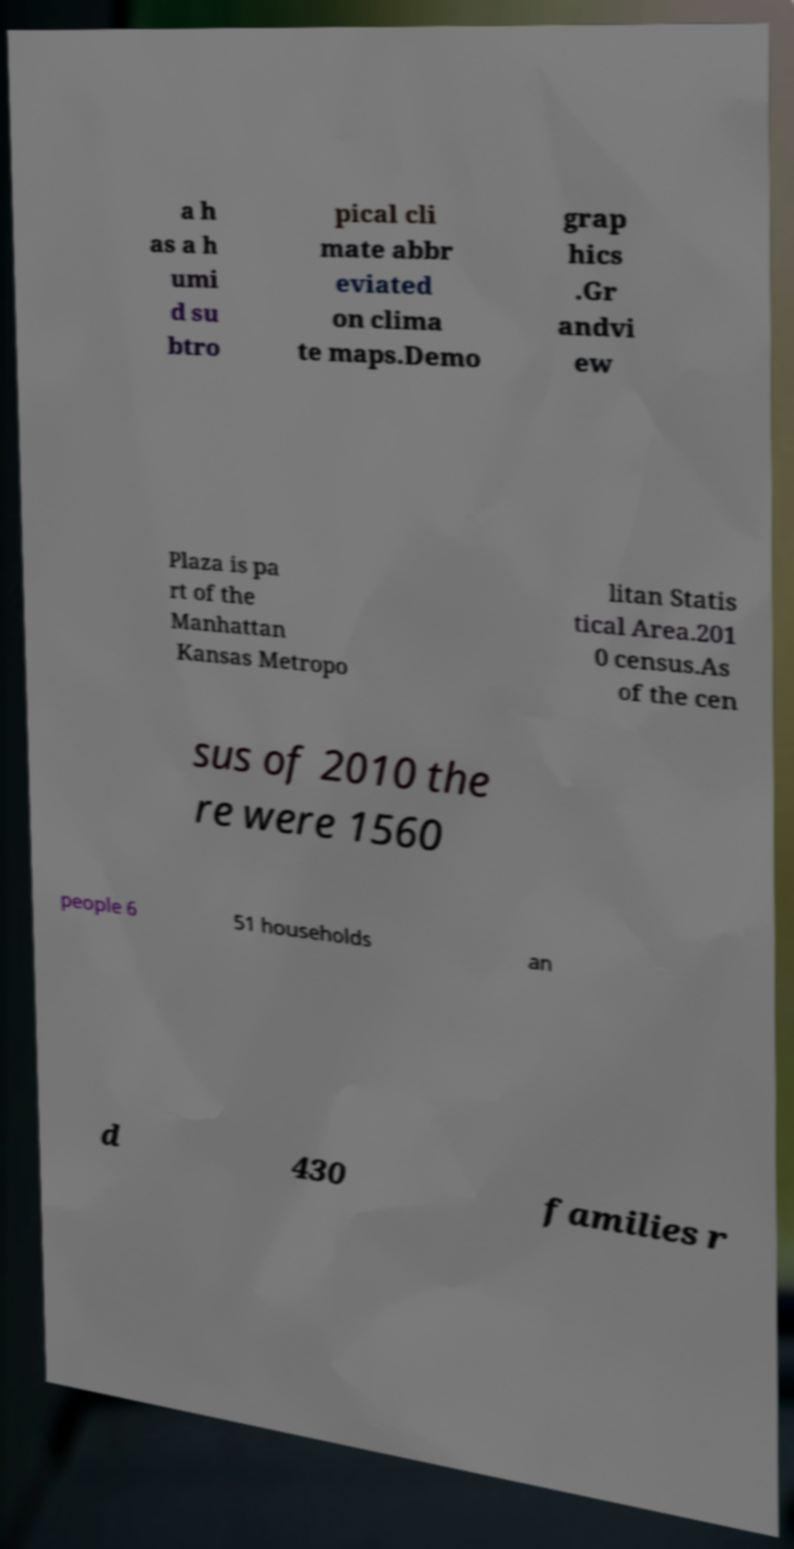Can you accurately transcribe the text from the provided image for me? a h as a h umi d su btro pical cli mate abbr eviated on clima te maps.Demo grap hics .Gr andvi ew Plaza is pa rt of the Manhattan Kansas Metropo litan Statis tical Area.201 0 census.As of the cen sus of 2010 the re were 1560 people 6 51 households an d 430 families r 